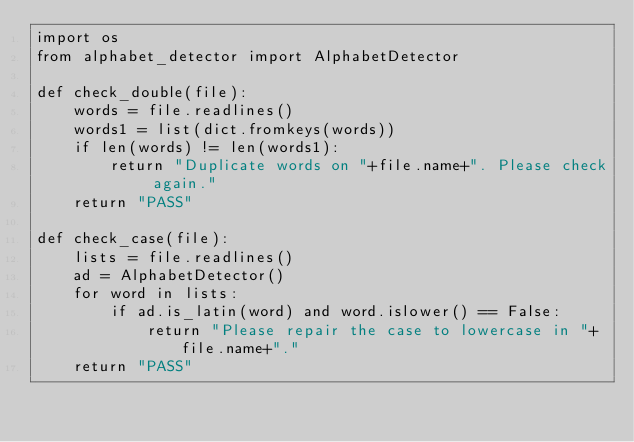Convert code to text. <code><loc_0><loc_0><loc_500><loc_500><_Python_>import os
from alphabet_detector import AlphabetDetector

def check_double(file):
    words = file.readlines()
    words1 = list(dict.fromkeys(words))
    if len(words) != len(words1):
        return "Duplicate words on "+file.name+". Please check again."
    return "PASS"

def check_case(file):
    lists = file.readlines()
    ad = AlphabetDetector()
    for word in lists:
        if ad.is_latin(word) and word.islower() == False:
            return "Please repair the case to lowercase in "+file.name+"."
    return "PASS"</code> 